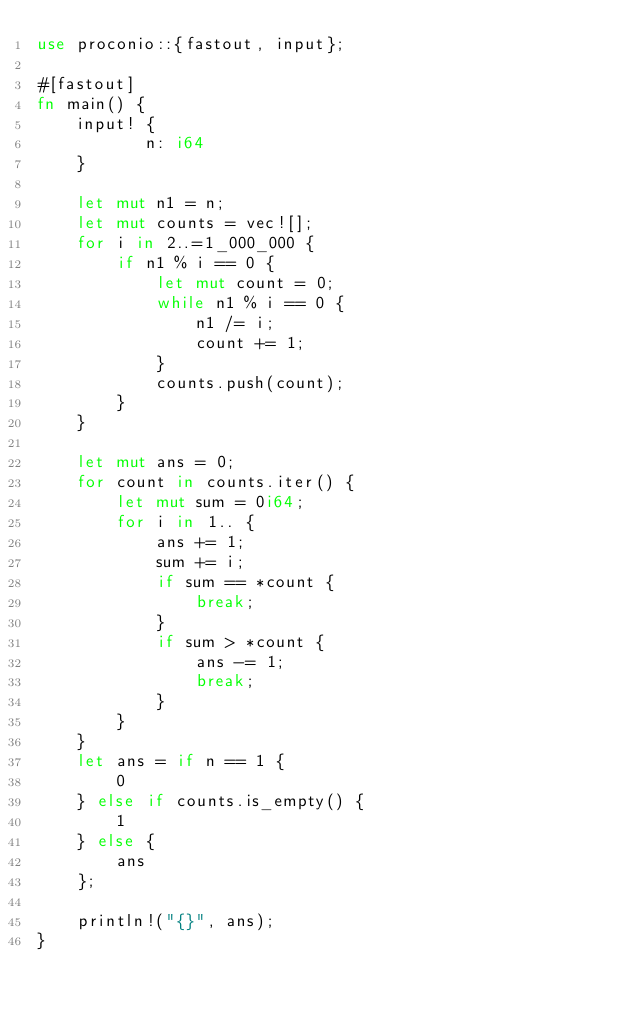Convert code to text. <code><loc_0><loc_0><loc_500><loc_500><_Rust_>use proconio::{fastout, input};

#[fastout]
fn main() {
    input! {
           n: i64
    }

    let mut n1 = n;
    let mut counts = vec![];
    for i in 2..=1_000_000 {
        if n1 % i == 0 {
            let mut count = 0;
            while n1 % i == 0 {
                n1 /= i;
                count += 1;
            }
            counts.push(count);
        }
    }

    let mut ans = 0;
    for count in counts.iter() {
        let mut sum = 0i64;
        for i in 1.. {
            ans += 1;
            sum += i;
            if sum == *count {
                break;
            }
            if sum > *count {
                ans -= 1;
                break;
            }
        }
    }
    let ans = if n == 1 {
        0
    } else if counts.is_empty() {
        1
    } else {
        ans
    };

    println!("{}", ans);
}
</code> 